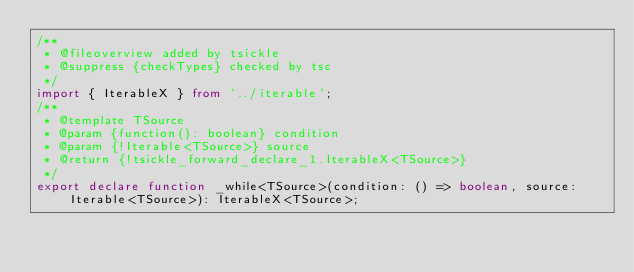<code> <loc_0><loc_0><loc_500><loc_500><_TypeScript_>/**
 * @fileoverview added by tsickle
 * @suppress {checkTypes} checked by tsc
 */
import { IterableX } from '../iterable';
/**
 * @template TSource
 * @param {function(): boolean} condition
 * @param {!Iterable<TSource>} source
 * @return {!tsickle_forward_declare_1.IterableX<TSource>}
 */
export declare function _while<TSource>(condition: () => boolean, source: Iterable<TSource>): IterableX<TSource>;
</code> 